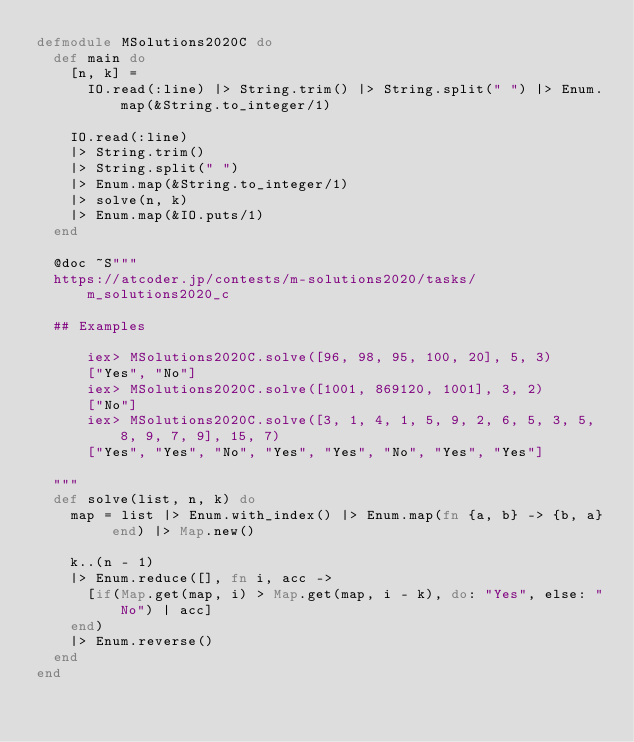Convert code to text. <code><loc_0><loc_0><loc_500><loc_500><_Elixir_>defmodule MSolutions2020C do
  def main do
    [n, k] =
      IO.read(:line) |> String.trim() |> String.split(" ") |> Enum.map(&String.to_integer/1)

    IO.read(:line)
    |> String.trim()
    |> String.split(" ")
    |> Enum.map(&String.to_integer/1)
    |> solve(n, k)
    |> Enum.map(&IO.puts/1)
  end

  @doc ~S"""
  https://atcoder.jp/contests/m-solutions2020/tasks/m_solutions2020_c

  ## Examples

      iex> MSolutions2020C.solve([96, 98, 95, 100, 20], 5, 3)
      ["Yes", "No"]
      iex> MSolutions2020C.solve([1001, 869120, 1001], 3, 2)
      ["No"]
      iex> MSolutions2020C.solve([3, 1, 4, 1, 5, 9, 2, 6, 5, 3, 5, 8, 9, 7, 9], 15, 7)
      ["Yes", "Yes", "No", "Yes", "Yes", "No", "Yes", "Yes"]

  """
  def solve(list, n, k) do
    map = list |> Enum.with_index() |> Enum.map(fn {a, b} -> {b, a} end) |> Map.new()

    k..(n - 1)
    |> Enum.reduce([], fn i, acc ->
      [if(Map.get(map, i) > Map.get(map, i - k), do: "Yes", else: "No") | acc]
    end)
    |> Enum.reverse()
  end
end
</code> 